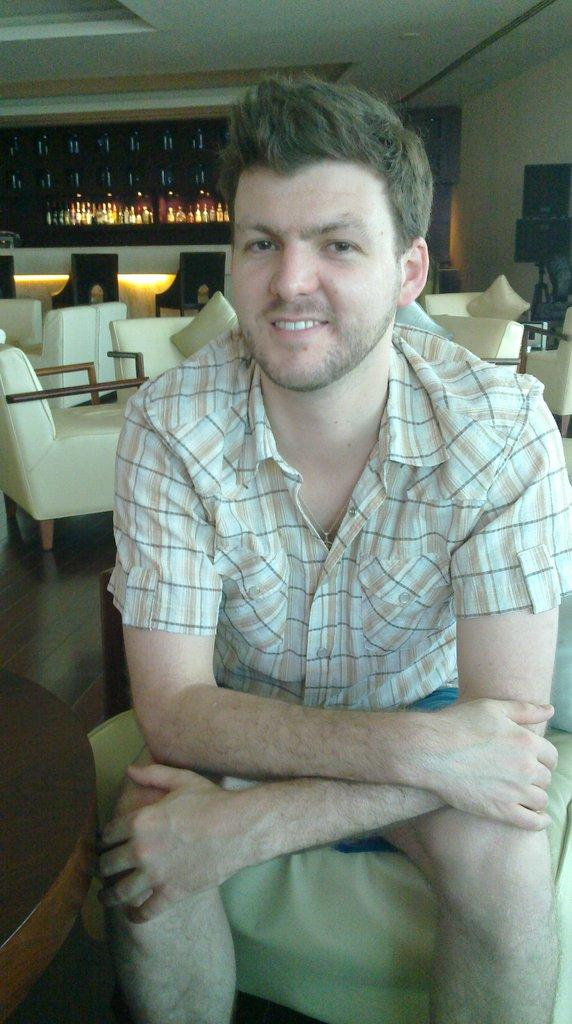Who is present in the image? There is a man in the image. What is the man wearing? The man is wearing clothes. What is the man doing in the image? The man is sitting. What can be seen in the background of the image? There is a table and a sofa chair in the image. What is the surface beneath the man's feet? There is a floor in the image. What objects are on a shelf in the image? There are bottles on a shelf in the image. What is the man's facial expression in the image? The man is smiling. How many cows are visible in the image? There are no cows present in the image. What type of curtain is hanging on the window in the image? There is no window or curtain visible in the image. 